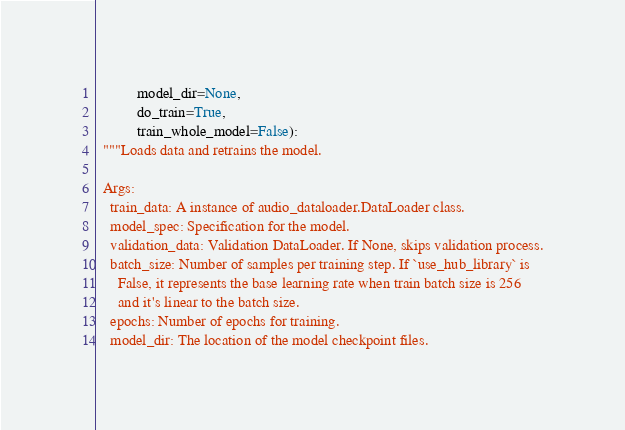Convert code to text. <code><loc_0><loc_0><loc_500><loc_500><_Python_>           model_dir=None,
           do_train=True,
           train_whole_model=False):
  """Loads data and retrains the model.

  Args:
    train_data: A instance of audio_dataloader.DataLoader class.
    model_spec: Specification for the model.
    validation_data: Validation DataLoader. If None, skips validation process.
    batch_size: Number of samples per training step. If `use_hub_library` is
      False, it represents the base learning rate when train batch size is 256
      and it's linear to the batch size.
    epochs: Number of epochs for training.
    model_dir: The location of the model checkpoint files.</code> 